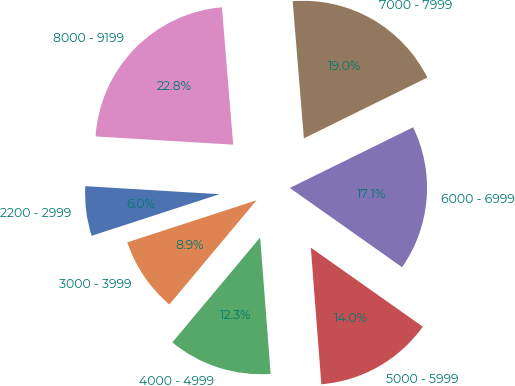Convert chart. <chart><loc_0><loc_0><loc_500><loc_500><pie_chart><fcel>2200 - 2999<fcel>3000 - 3999<fcel>4000 - 4999<fcel>5000 - 5999<fcel>6000 - 6999<fcel>7000 - 7999<fcel>8000 - 9199<nl><fcel>5.96%<fcel>8.9%<fcel>12.31%<fcel>13.99%<fcel>17.06%<fcel>19.02%<fcel>22.75%<nl></chart> 